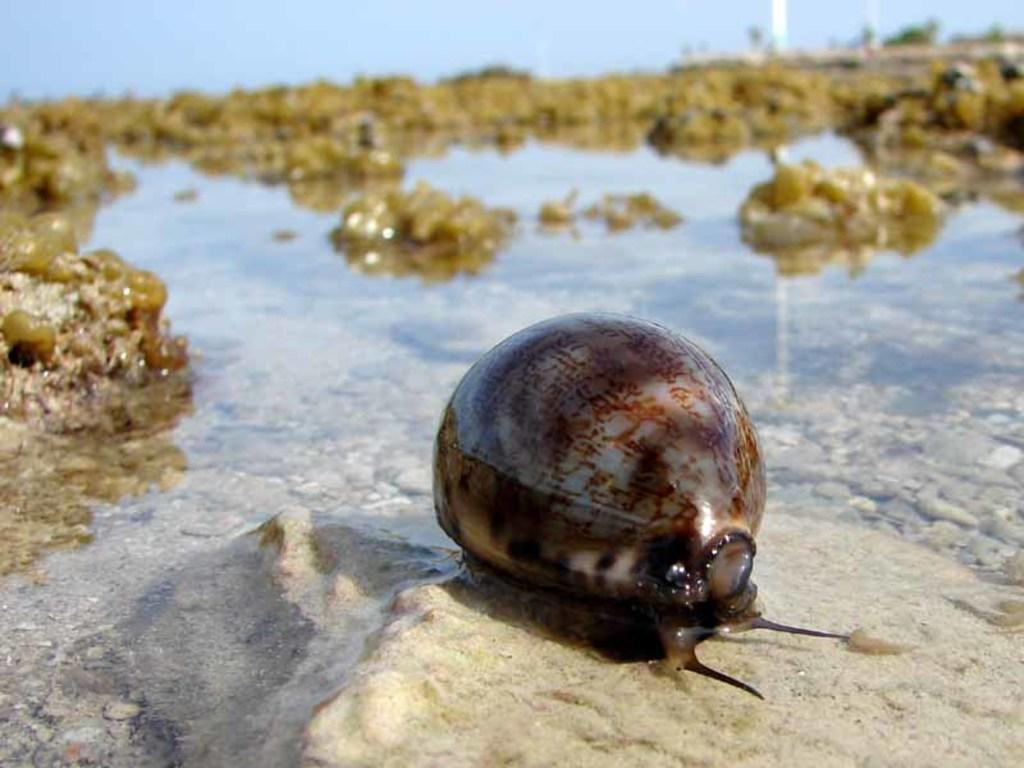What is the main subject of the image? There is a snail on the surface of water in the image. What can be seen in the background of the image? There are rocks and water visible in the background of the image. What type of watch is the snail wearing in the image? There is no watch present in the image; the snail is not wearing any accessories. 